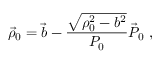Convert formula to latex. <formula><loc_0><loc_0><loc_500><loc_500>\vec { \rho } _ { 0 } = \vec { b } - \frac { \sqrt { \rho _ { 0 } ^ { 2 } - b ^ { 2 } } } { P _ { 0 } } \vec { P } _ { 0 } ,</formula> 